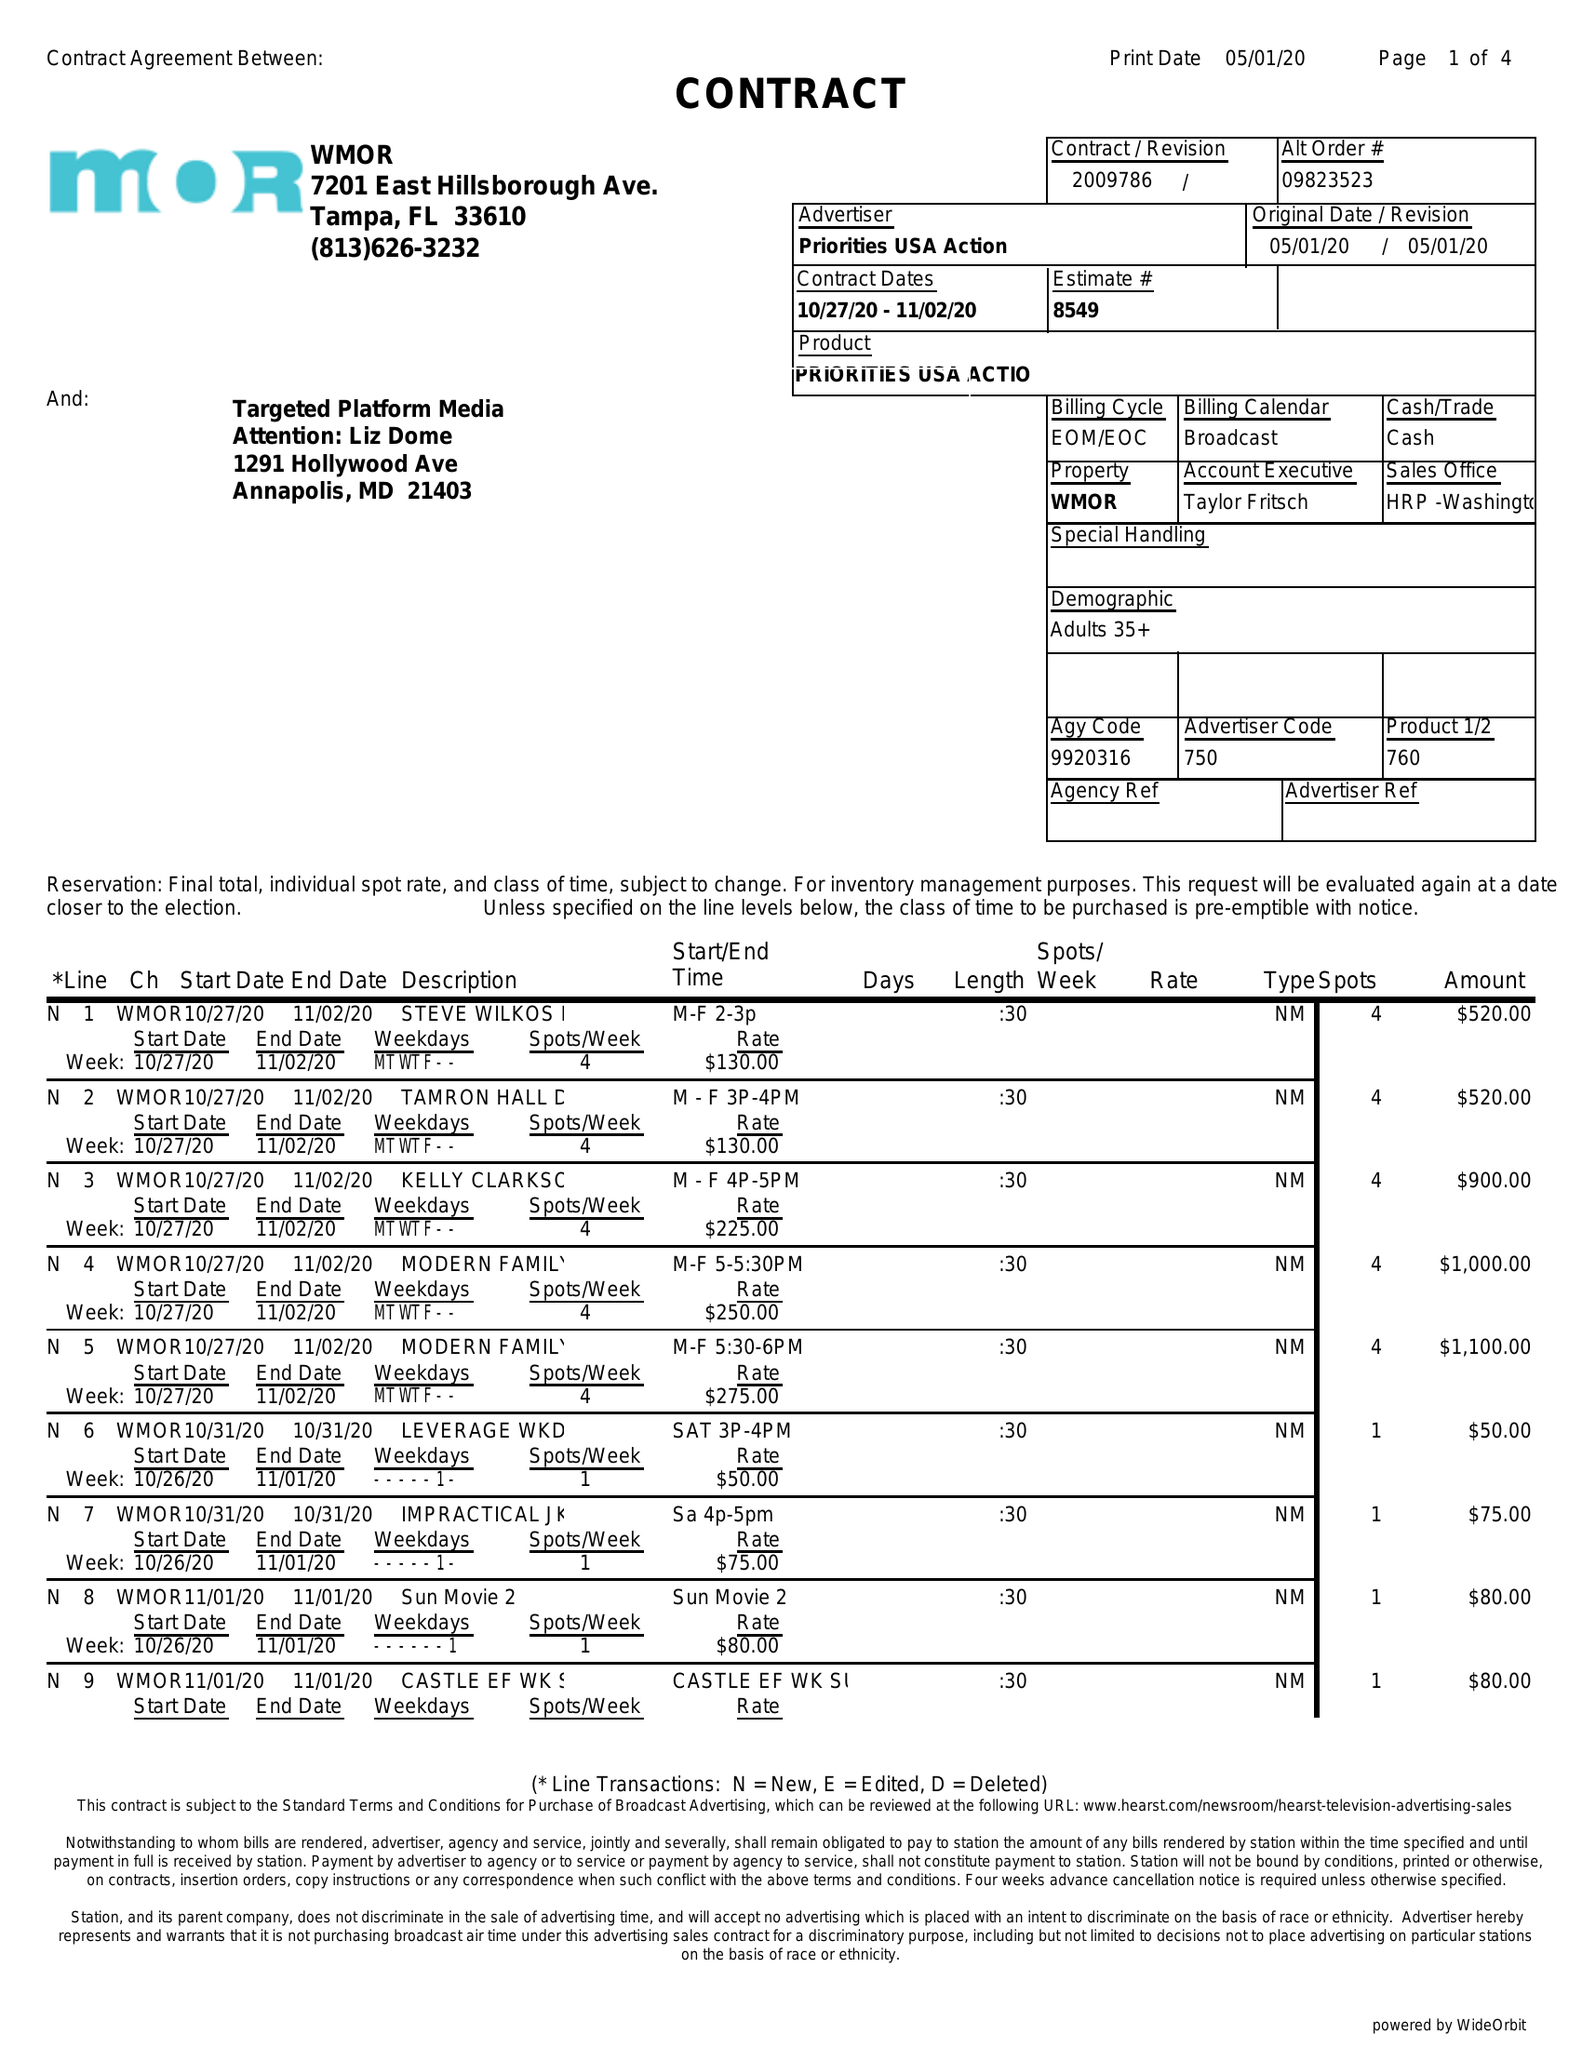What is the value for the flight_from?
Answer the question using a single word or phrase. 10/27/20 